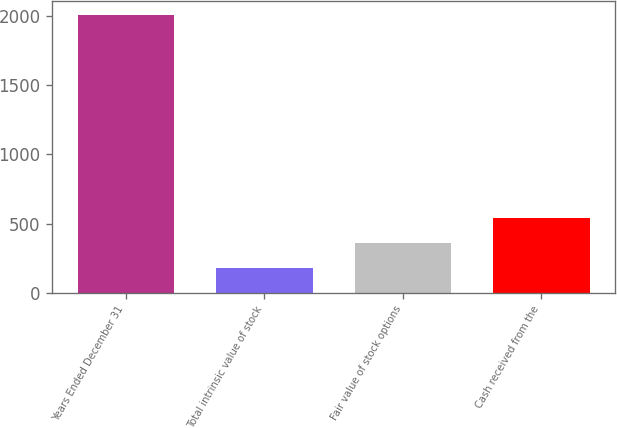<chart> <loc_0><loc_0><loc_500><loc_500><bar_chart><fcel>Years Ended December 31<fcel>Total intrinsic value of stock<fcel>Fair value of stock options<fcel>Cash received from the<nl><fcel>2010<fcel>177<fcel>360.3<fcel>543.6<nl></chart> 